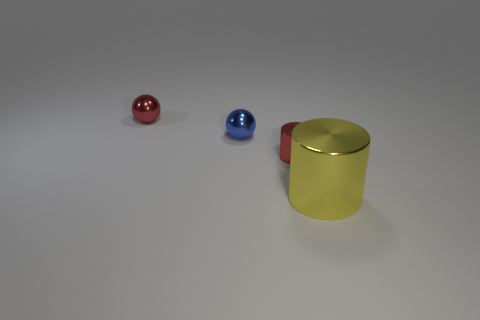How many small shiny cylinders are the same color as the big object?
Your answer should be very brief. 0. There is another ball that is the same size as the blue shiny sphere; what is its material?
Ensure brevity in your answer.  Metal. Are there any small red shiny cylinders in front of the tiny red metal object that is right of the red ball?
Your answer should be very brief. No. How many other objects are the same color as the large thing?
Your answer should be compact. 0. What size is the red shiny cylinder?
Your answer should be very brief. Small. Is there a red metal cylinder?
Your answer should be compact. Yes. Are there more tiny red metallic objects that are left of the small red sphere than small red shiny cylinders that are in front of the red metal cylinder?
Make the answer very short. No. The small thing that is both in front of the red metallic sphere and to the left of the small red cylinder is made of what material?
Provide a short and direct response. Metal. Does the big yellow object have the same shape as the blue shiny object?
Your answer should be very brief. No. Is there any other thing that has the same size as the yellow metallic cylinder?
Make the answer very short. No. 